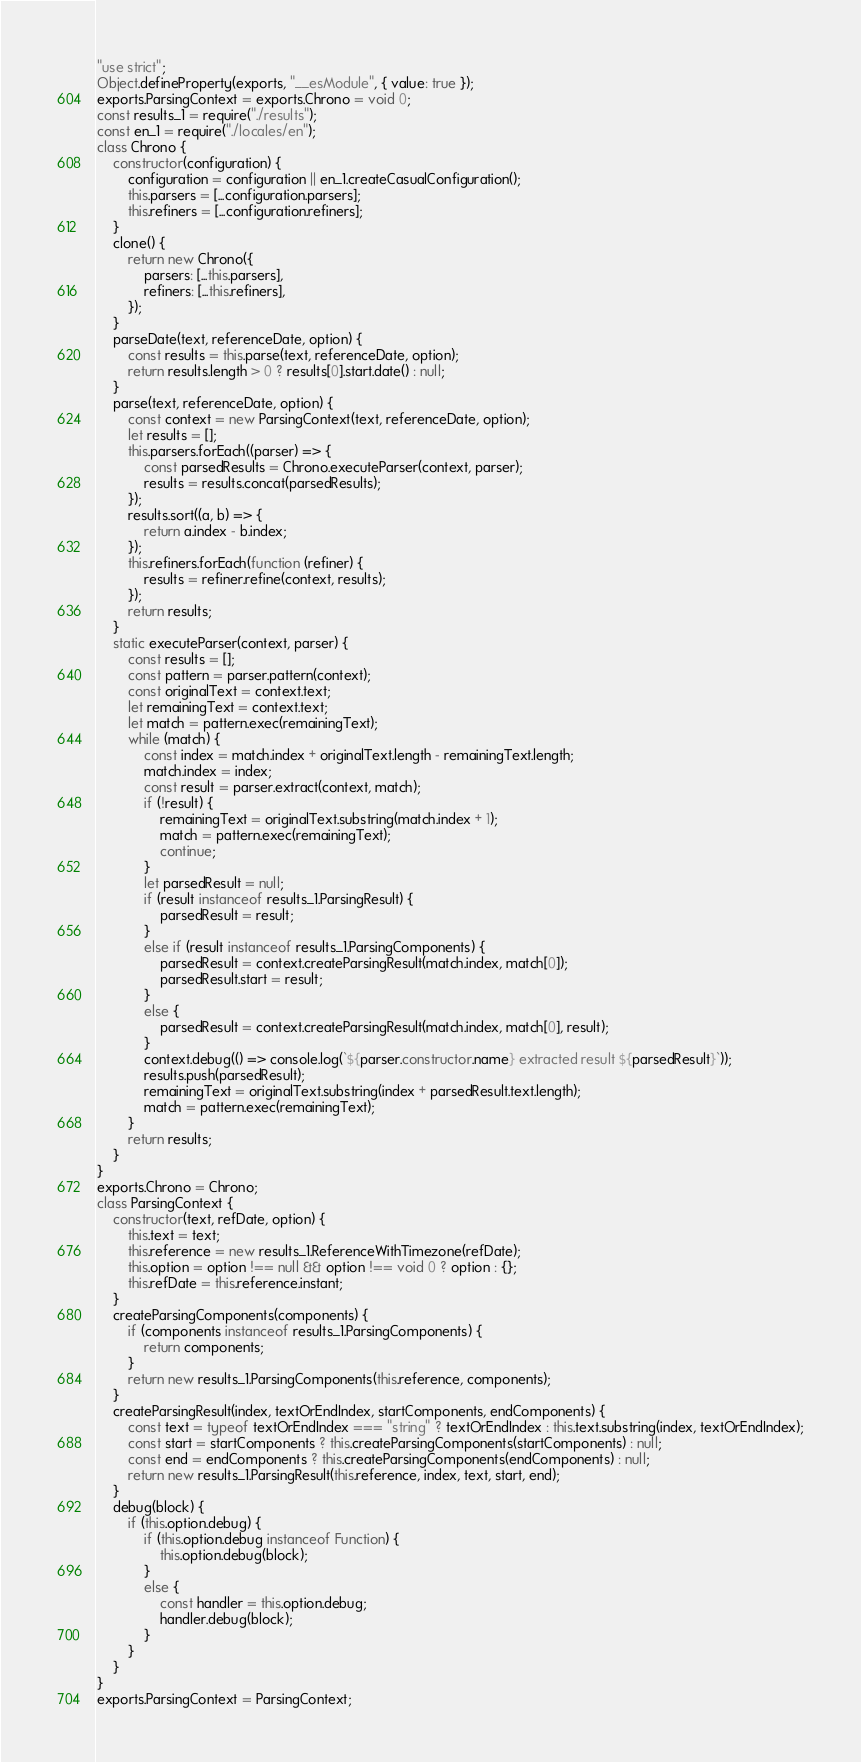<code> <loc_0><loc_0><loc_500><loc_500><_JavaScript_>"use strict";
Object.defineProperty(exports, "__esModule", { value: true });
exports.ParsingContext = exports.Chrono = void 0;
const results_1 = require("./results");
const en_1 = require("./locales/en");
class Chrono {
    constructor(configuration) {
        configuration = configuration || en_1.createCasualConfiguration();
        this.parsers = [...configuration.parsers];
        this.refiners = [...configuration.refiners];
    }
    clone() {
        return new Chrono({
            parsers: [...this.parsers],
            refiners: [...this.refiners],
        });
    }
    parseDate(text, referenceDate, option) {
        const results = this.parse(text, referenceDate, option);
        return results.length > 0 ? results[0].start.date() : null;
    }
    parse(text, referenceDate, option) {
        const context = new ParsingContext(text, referenceDate, option);
        let results = [];
        this.parsers.forEach((parser) => {
            const parsedResults = Chrono.executeParser(context, parser);
            results = results.concat(parsedResults);
        });
        results.sort((a, b) => {
            return a.index - b.index;
        });
        this.refiners.forEach(function (refiner) {
            results = refiner.refine(context, results);
        });
        return results;
    }
    static executeParser(context, parser) {
        const results = [];
        const pattern = parser.pattern(context);
        const originalText = context.text;
        let remainingText = context.text;
        let match = pattern.exec(remainingText);
        while (match) {
            const index = match.index + originalText.length - remainingText.length;
            match.index = index;
            const result = parser.extract(context, match);
            if (!result) {
                remainingText = originalText.substring(match.index + 1);
                match = pattern.exec(remainingText);
                continue;
            }
            let parsedResult = null;
            if (result instanceof results_1.ParsingResult) {
                parsedResult = result;
            }
            else if (result instanceof results_1.ParsingComponents) {
                parsedResult = context.createParsingResult(match.index, match[0]);
                parsedResult.start = result;
            }
            else {
                parsedResult = context.createParsingResult(match.index, match[0], result);
            }
            context.debug(() => console.log(`${parser.constructor.name} extracted result ${parsedResult}`));
            results.push(parsedResult);
            remainingText = originalText.substring(index + parsedResult.text.length);
            match = pattern.exec(remainingText);
        }
        return results;
    }
}
exports.Chrono = Chrono;
class ParsingContext {
    constructor(text, refDate, option) {
        this.text = text;
        this.reference = new results_1.ReferenceWithTimezone(refDate);
        this.option = option !== null && option !== void 0 ? option : {};
        this.refDate = this.reference.instant;
    }
    createParsingComponents(components) {
        if (components instanceof results_1.ParsingComponents) {
            return components;
        }
        return new results_1.ParsingComponents(this.reference, components);
    }
    createParsingResult(index, textOrEndIndex, startComponents, endComponents) {
        const text = typeof textOrEndIndex === "string" ? textOrEndIndex : this.text.substring(index, textOrEndIndex);
        const start = startComponents ? this.createParsingComponents(startComponents) : null;
        const end = endComponents ? this.createParsingComponents(endComponents) : null;
        return new results_1.ParsingResult(this.reference, index, text, start, end);
    }
    debug(block) {
        if (this.option.debug) {
            if (this.option.debug instanceof Function) {
                this.option.debug(block);
            }
            else {
                const handler = this.option.debug;
                handler.debug(block);
            }
        }
    }
}
exports.ParsingContext = ParsingContext;
</code> 